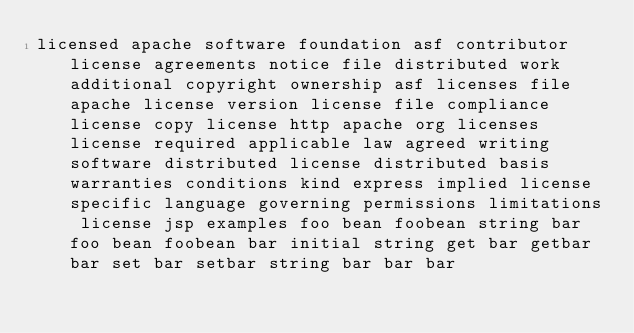<code> <loc_0><loc_0><loc_500><loc_500><_Java_>licensed apache software foundation asf contributor license agreements notice file distributed work additional copyright ownership asf licenses file apache license version license file compliance license copy license http apache org licenses license required applicable law agreed writing software distributed license distributed basis warranties conditions kind express implied license specific language governing permissions limitations license jsp examples foo bean foobean string bar foo bean foobean bar initial string get bar getbar bar set bar setbar string bar bar bar</code> 